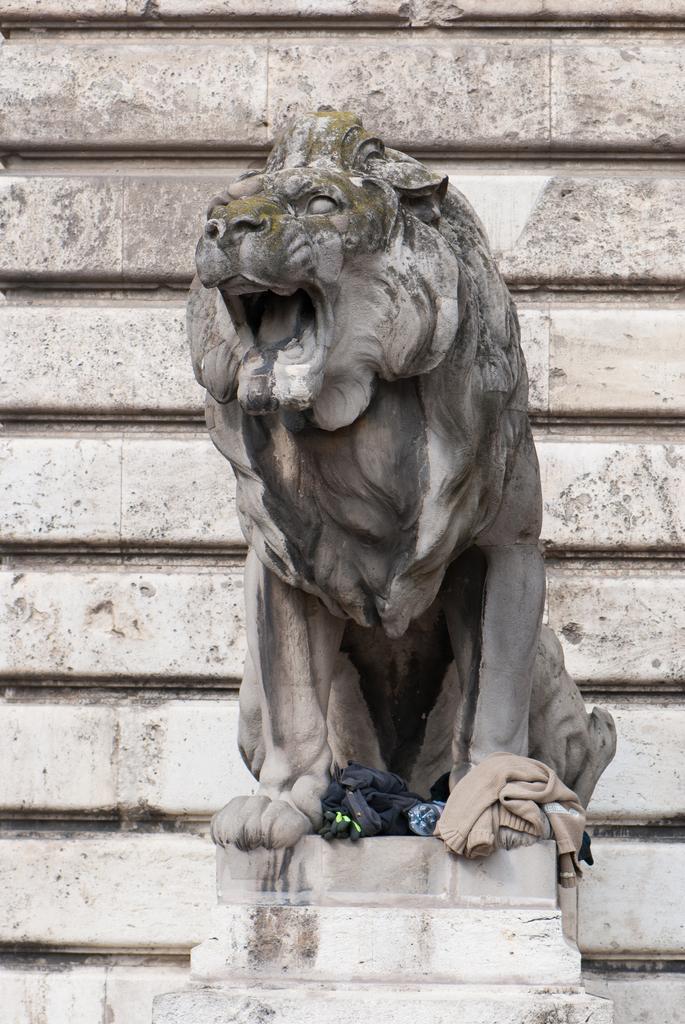Describe this image in one or two sentences. In this image there is a depiction of a lion and there are few clothes and a bottle. In the background there is a wall. 